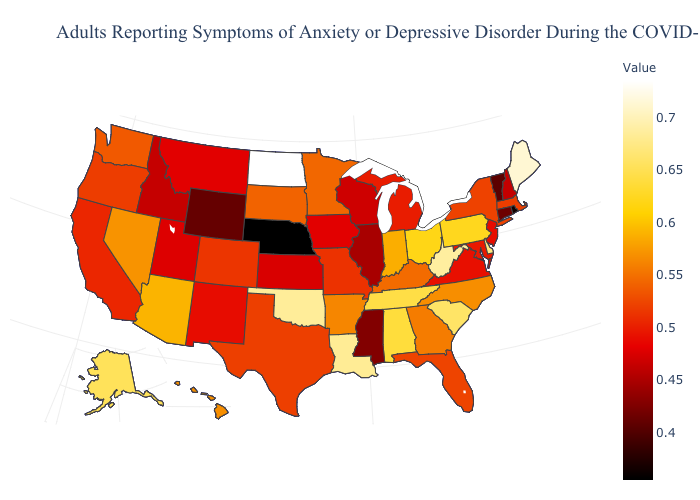Among the states that border Nevada , does Oregon have the lowest value?
Answer briefly. No. Does Wyoming have the lowest value in the West?
Quick response, please. Yes. Among the states that border Kentucky , does Virginia have the lowest value?
Give a very brief answer. No. Among the states that border Indiana , does Illinois have the lowest value?
Give a very brief answer. Yes. Which states hav the highest value in the South?
Quick response, please. West Virginia. Does New York have a lower value than Rhode Island?
Answer briefly. No. Does North Dakota have the highest value in the USA?
Be succinct. Yes. 